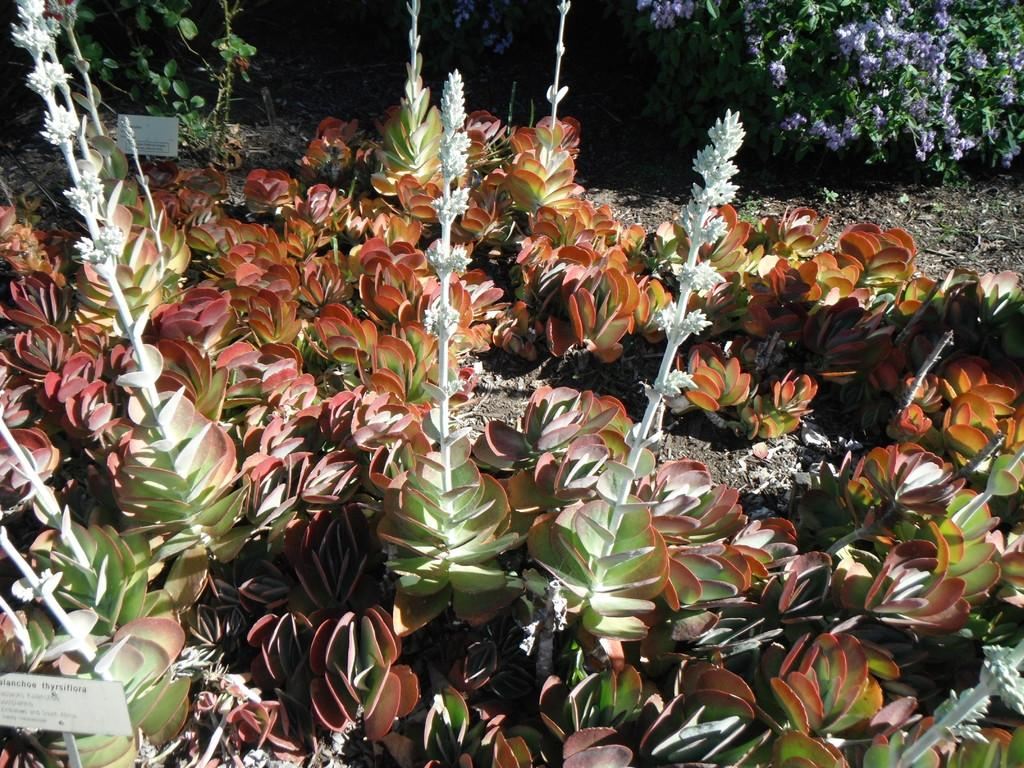What can be seen in the foreground of the image? There are many plants on the ground in the foreground of the image. Is there any text or label visible in the image? Yes, there is a name plate in the left bottom corner of the image. What is visible in the top part of the image? There are trees and flowers in the top part of the image. How many cars are parked in the bedroom in the image? There is no bedroom or cars present in the image. What role does the digestion process play in the growth of the flowers in the image? The image does not depict any digestion process, and the growth of flowers is not related to digestion. 